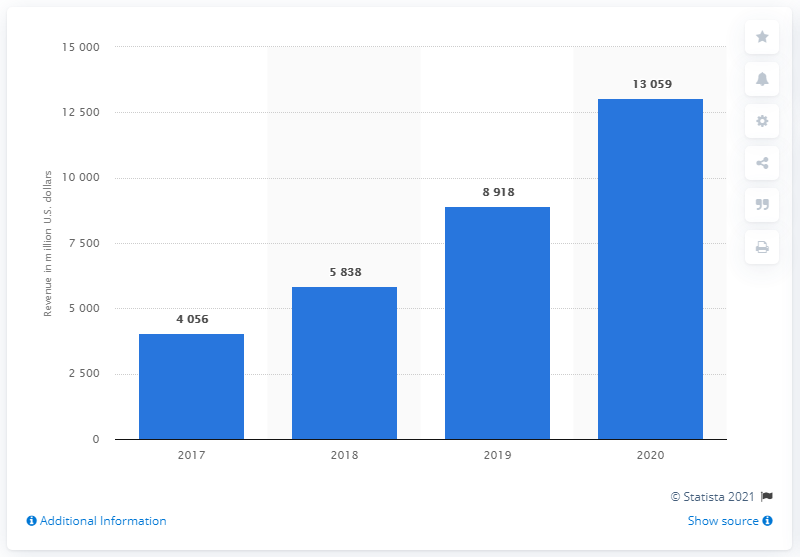List a handful of essential elements in this visual. Google's Cloud revenue in 2020 was approximately 13,059. 